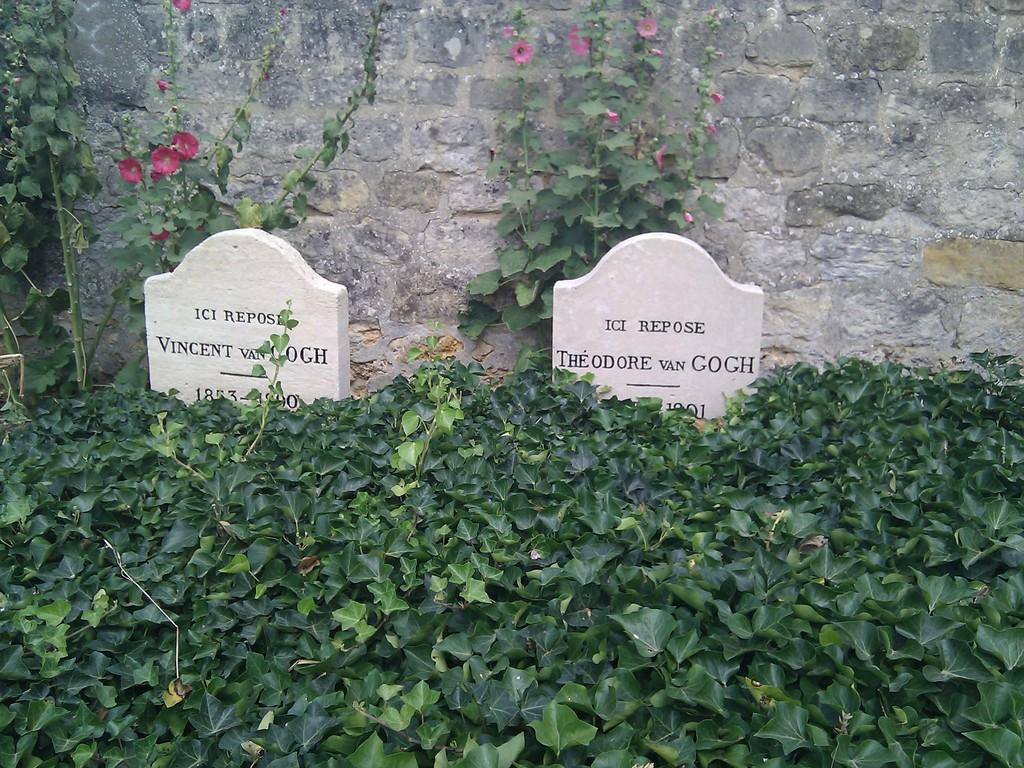Provide a one-sentence caption for the provided image. The gravesite for Vincent VanGogh sits next to the burial place of Theodore VanGogh. 